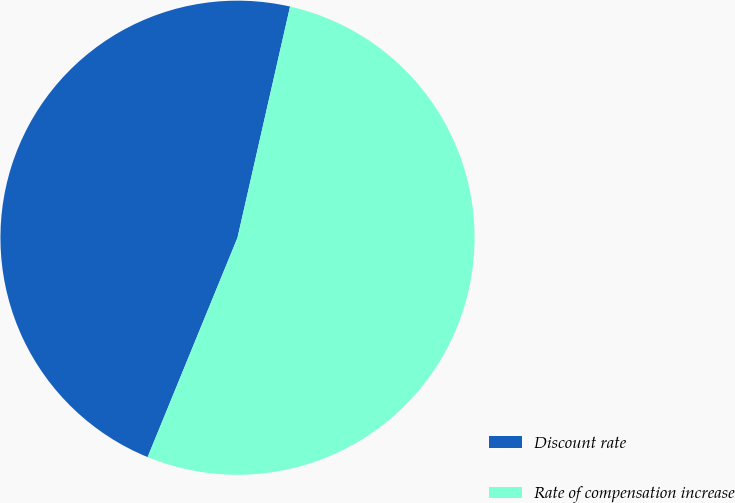Convert chart to OTSL. <chart><loc_0><loc_0><loc_500><loc_500><pie_chart><fcel>Discount rate<fcel>Rate of compensation increase<nl><fcel>47.37%<fcel>52.63%<nl></chart> 